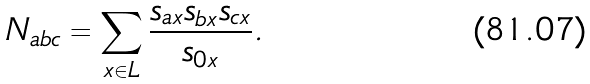Convert formula to latex. <formula><loc_0><loc_0><loc_500><loc_500>N _ { a b c } = \sum _ { x \in L } \frac { s _ { a x } s _ { b x } s _ { c x } } { s _ { 0 x } } .</formula> 